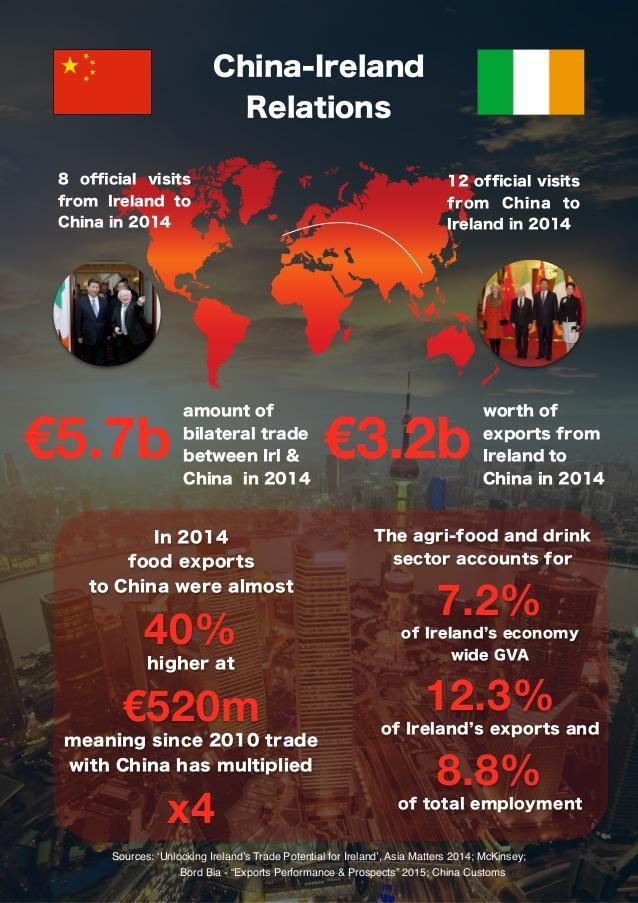In 2014, how many official visits were there from Ireland to China?
Answer the question with a short phrase. 8 In 2014, how many official visits were there to Ireland from China? 12 what accounts for 7.2% of economy? agri-food and drink sector What was the % increase in food exports to China? 40% What has increased 4 times since 2010? trade with China 